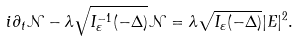Convert formula to latex. <formula><loc_0><loc_0><loc_500><loc_500>i \partial _ { t } \mathcal { N } - \lambda \sqrt { I _ { \varepsilon } ^ { - 1 } ( - \Delta ) } \mathcal { N } = \lambda \sqrt { I _ { \varepsilon } ( - \Delta ) } | E | ^ { 2 } .</formula> 